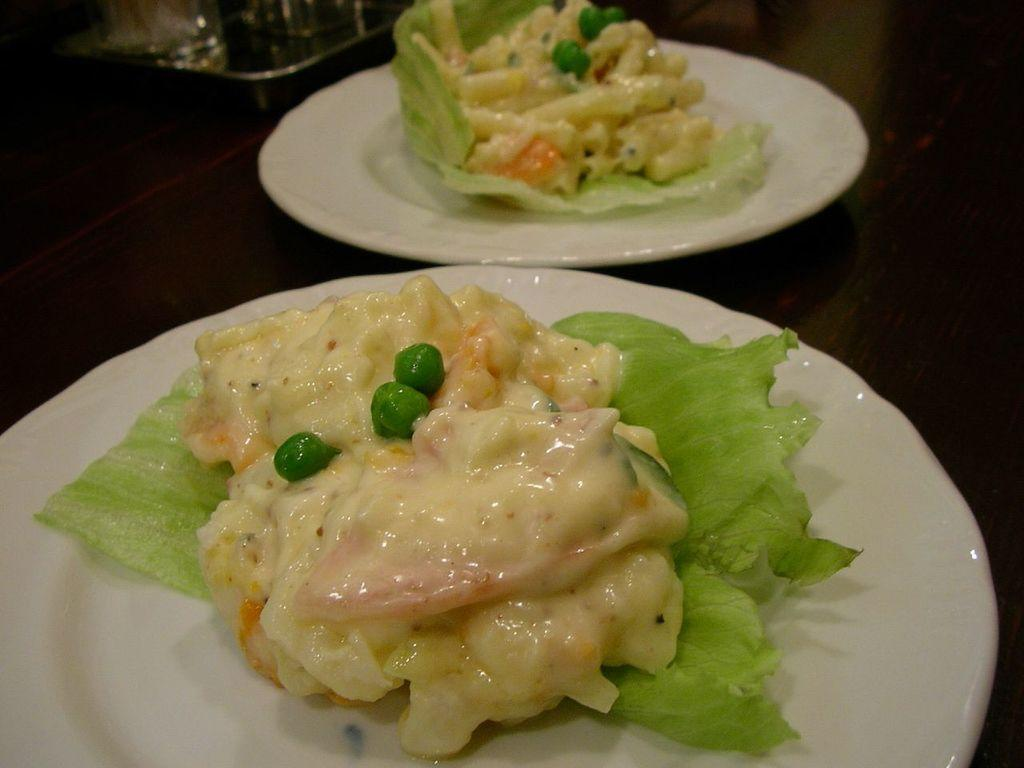What type of food can be seen in the image? The food in the image has cream and green colors. How is the food arranged in the image? The food is in a plate. What color is the plate? The plate is white. What is the background of the image? The background of the image contains the same food in a plate. Where is the grandmother sitting in the image? There is no grandmother present in the image. What type of cracker is placed on the bed in the image? There is no bed or cracker present in the image. 